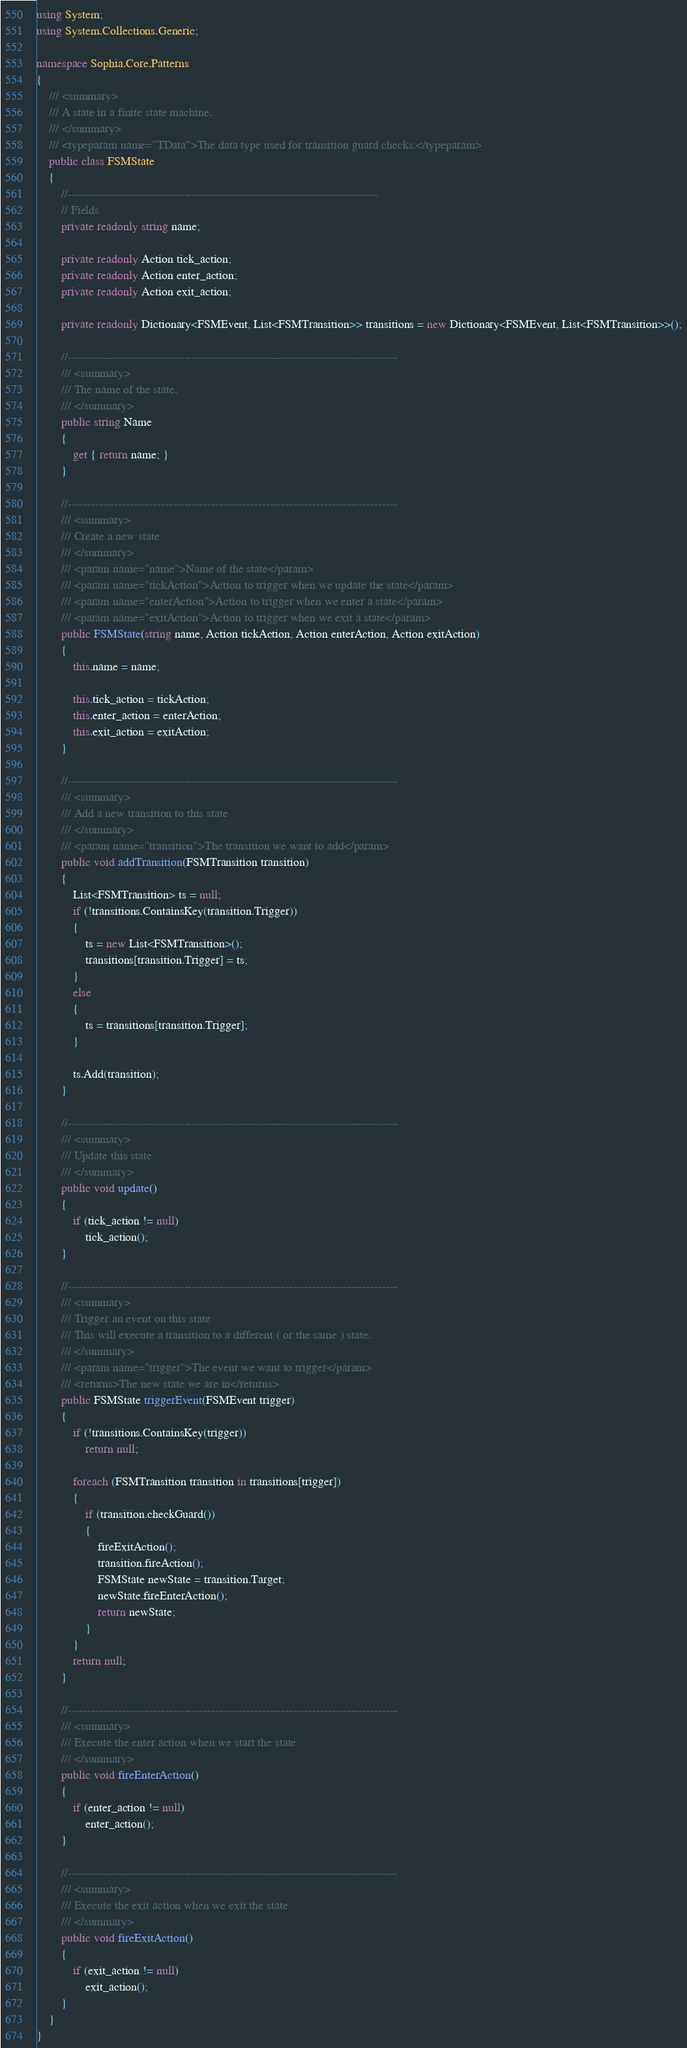Convert code to text. <code><loc_0><loc_0><loc_500><loc_500><_C#_>using System;
using System.Collections.Generic;

namespace Sophia.Core.Patterns
{
    /// <summary>
    /// A state in a finite state machine.
    /// </summary>
    /// <typeparam name="TData">The data type used for transition guard checks.</typeparam>
    public class FSMState
    {
        //--------------------------------------------------------------------------------
        // Fields
        private readonly string name;

        private readonly Action tick_action;
        private readonly Action enter_action;
        private readonly Action exit_action;

        private readonly Dictionary<FSMEvent, List<FSMTransition>> transitions = new Dictionary<FSMEvent, List<FSMTransition>>();

        //-------------------------------------------------------------------------------------	
        /// <summary>
        /// The name of the state.
        /// </summary>
        public string Name
        {
            get { return name; }
        }

        //-------------------------------------------------------------------------------------
        /// <summary>
        /// Create a new state
        /// </summary>
        /// <param name="name">Name of the state</param>
        /// <param name="tickAction">Action to trigger when we update the state</param>
        /// <param name="enterAction">Action to trigger when we enter a state</param>
        /// <param name="exitAction">Action to trigger when we exit a state</param>
        public FSMState(string name, Action tickAction, Action enterAction, Action exitAction)
        {
            this.name = name;

            this.tick_action = tickAction;
            this.enter_action = enterAction;
            this.exit_action = exitAction;
        }

        //-------------------------------------------------------------------------------------
        /// <summary>
        /// Add a new transition to this state
        /// </summary>
        /// <param name="transition">The transition we want to add</param>
        public void addTransition(FSMTransition transition)
        {
            List<FSMTransition> ts = null;
            if (!transitions.ContainsKey(transition.Trigger))
            {
                ts = new List<FSMTransition>();
                transitions[transition.Trigger] = ts;
            }
            else
            {
                ts = transitions[transition.Trigger];
            }

            ts.Add(transition);
        }

        //-------------------------------------------------------------------------------------
        /// <summary>
        /// Update this state
        /// </summary>
        public void update()
        {
            if (tick_action != null)
                tick_action();
        }

        //-------------------------------------------------------------------------------------
        /// <summary>
        /// Trigger an event on this state
        /// This will execute a transition to a different ( or the same ) state.
        /// </summary>
        /// <param name="trigger">The event we want to trigger</param>
        /// <returns>The new state we are in</returns>
        public FSMState triggerEvent(FSMEvent trigger)
        {
            if (!transitions.ContainsKey(trigger))
                return null;

            foreach (FSMTransition transition in transitions[trigger])
            {
                if (transition.checkGuard())
                {
                    fireExitAction();
                    transition.fireAction();
                    FSMState newState = transition.Target;
                    newState.fireEnterAction();
                    return newState;
                }
            }
            return null;
        }

        //-------------------------------------------------------------------------------------
        /// <summary>
        /// Execute the enter action when we start the state
        /// </summary>
        public void fireEnterAction()
        {
            if (enter_action != null)
                enter_action();
        }

        //-------------------------------------------------------------------------------------
        /// <summary>
        /// Execute the exit action when we exit the state
        /// </summary>
        public void fireExitAction()
        {
            if (exit_action != null)
                exit_action();
        }
    }
}
</code> 